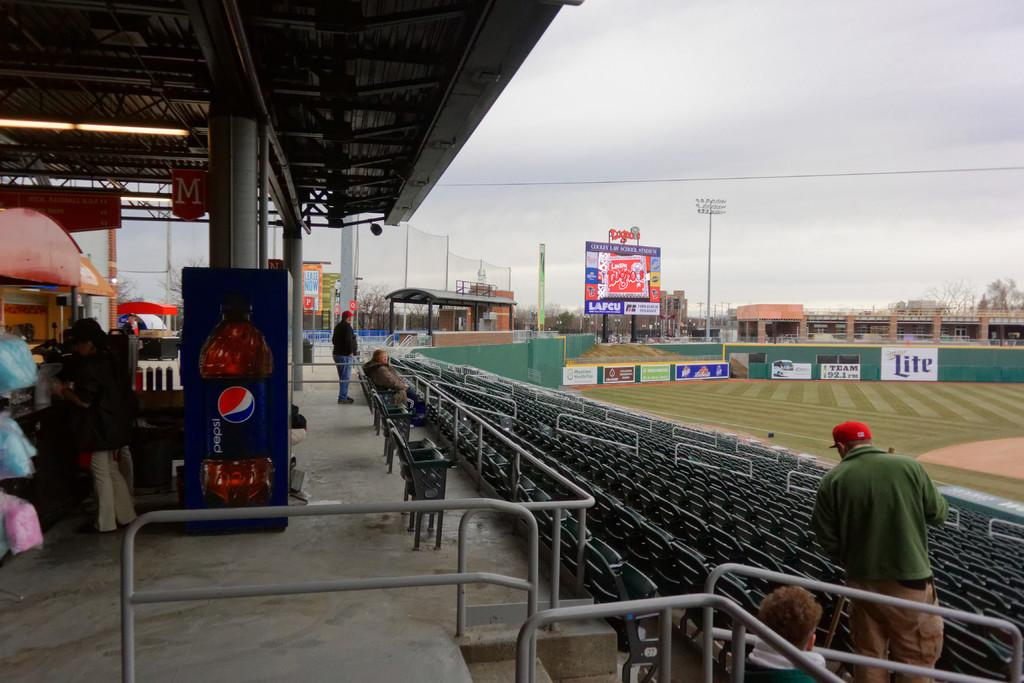<image>
Provide a brief description of the given image. A pepsi machine at the top of a set of stadium bleachers. 